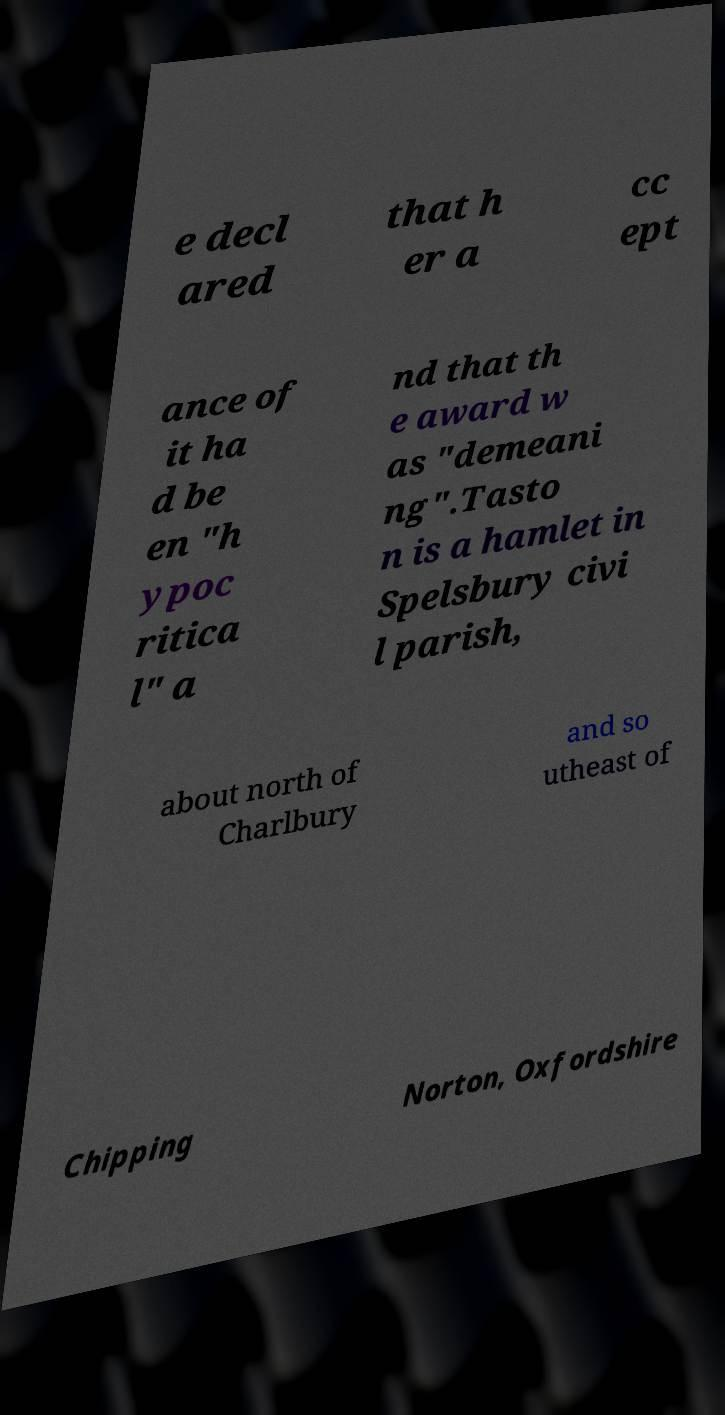There's text embedded in this image that I need extracted. Can you transcribe it verbatim? e decl ared that h er a cc ept ance of it ha d be en "h ypoc ritica l" a nd that th e award w as "demeani ng".Tasto n is a hamlet in Spelsbury civi l parish, about north of Charlbury and so utheast of Chipping Norton, Oxfordshire 